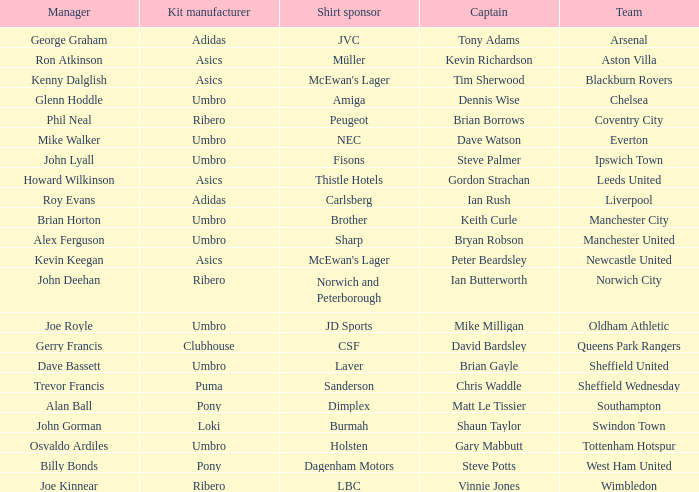Give me the full table as a dictionary. {'header': ['Manager', 'Kit manufacturer', 'Shirt sponsor', 'Captain', 'Team'], 'rows': [['George Graham', 'Adidas', 'JVC', 'Tony Adams', 'Arsenal'], ['Ron Atkinson', 'Asics', 'Müller', 'Kevin Richardson', 'Aston Villa'], ['Kenny Dalglish', 'Asics', "McEwan's Lager", 'Tim Sherwood', 'Blackburn Rovers'], ['Glenn Hoddle', 'Umbro', 'Amiga', 'Dennis Wise', 'Chelsea'], ['Phil Neal', 'Ribero', 'Peugeot', 'Brian Borrows', 'Coventry City'], ['Mike Walker', 'Umbro', 'NEC', 'Dave Watson', 'Everton'], ['John Lyall', 'Umbro', 'Fisons', 'Steve Palmer', 'Ipswich Town'], ['Howard Wilkinson', 'Asics', 'Thistle Hotels', 'Gordon Strachan', 'Leeds United'], ['Roy Evans', 'Adidas', 'Carlsberg', 'Ian Rush', 'Liverpool'], ['Brian Horton', 'Umbro', 'Brother', 'Keith Curle', 'Manchester City'], ['Alex Ferguson', 'Umbro', 'Sharp', 'Bryan Robson', 'Manchester United'], ['Kevin Keegan', 'Asics', "McEwan's Lager", 'Peter Beardsley', 'Newcastle United'], ['John Deehan', 'Ribero', 'Norwich and Peterborough', 'Ian Butterworth', 'Norwich City'], ['Joe Royle', 'Umbro', 'JD Sports', 'Mike Milligan', 'Oldham Athletic'], ['Gerry Francis', 'Clubhouse', 'CSF', 'David Bardsley', 'Queens Park Rangers'], ['Dave Bassett', 'Umbro', 'Laver', 'Brian Gayle', 'Sheffield United'], ['Trevor Francis', 'Puma', 'Sanderson', 'Chris Waddle', 'Sheffield Wednesday'], ['Alan Ball', 'Pony', 'Dimplex', 'Matt Le Tissier', 'Southampton'], ['John Gorman', 'Loki', 'Burmah', 'Shaun Taylor', 'Swindon Town'], ['Osvaldo Ardiles', 'Umbro', 'Holsten', 'Gary Mabbutt', 'Tottenham Hotspur'], ['Billy Bonds', 'Pony', 'Dagenham Motors', 'Steve Potts', 'West Ham United'], ['Joe Kinnear', 'Ribero', 'LBC', 'Vinnie Jones', 'Wimbledon']]} Which manager has Manchester City as the team? Brian Horton. 